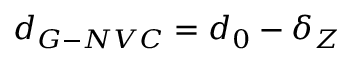<formula> <loc_0><loc_0><loc_500><loc_500>{ d _ { G - N V C } } = d _ { 0 } - \delta _ { Z }</formula> 